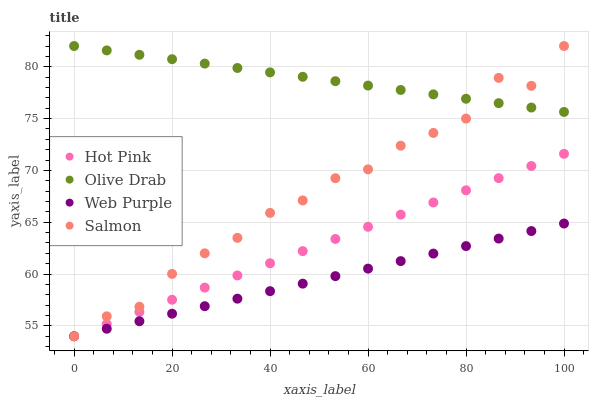Does Web Purple have the minimum area under the curve?
Answer yes or no. Yes. Does Olive Drab have the maximum area under the curve?
Answer yes or no. Yes. Does Hot Pink have the minimum area under the curve?
Answer yes or no. No. Does Hot Pink have the maximum area under the curve?
Answer yes or no. No. Is Web Purple the smoothest?
Answer yes or no. Yes. Is Salmon the roughest?
Answer yes or no. Yes. Is Hot Pink the smoothest?
Answer yes or no. No. Is Hot Pink the roughest?
Answer yes or no. No. Does Web Purple have the lowest value?
Answer yes or no. Yes. Does Olive Drab have the lowest value?
Answer yes or no. No. Does Olive Drab have the highest value?
Answer yes or no. Yes. Does Hot Pink have the highest value?
Answer yes or no. No. Is Web Purple less than Olive Drab?
Answer yes or no. Yes. Is Olive Drab greater than Web Purple?
Answer yes or no. Yes. Does Salmon intersect Web Purple?
Answer yes or no. Yes. Is Salmon less than Web Purple?
Answer yes or no. No. Is Salmon greater than Web Purple?
Answer yes or no. No. Does Web Purple intersect Olive Drab?
Answer yes or no. No. 